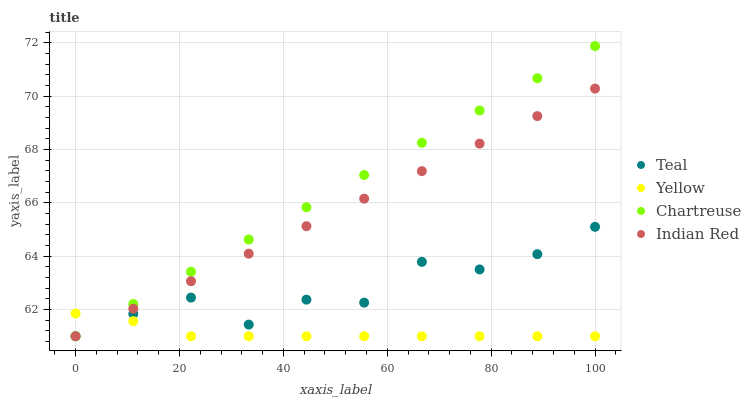Does Yellow have the minimum area under the curve?
Answer yes or no. Yes. Does Chartreuse have the maximum area under the curve?
Answer yes or no. Yes. Does Chartreuse have the minimum area under the curve?
Answer yes or no. No. Does Yellow have the maximum area under the curve?
Answer yes or no. No. Is Indian Red the smoothest?
Answer yes or no. Yes. Is Teal the roughest?
Answer yes or no. Yes. Is Chartreuse the smoothest?
Answer yes or no. No. Is Chartreuse the roughest?
Answer yes or no. No. Does Indian Red have the lowest value?
Answer yes or no. Yes. Does Chartreuse have the highest value?
Answer yes or no. Yes. Does Yellow have the highest value?
Answer yes or no. No. Does Chartreuse intersect Yellow?
Answer yes or no. Yes. Is Chartreuse less than Yellow?
Answer yes or no. No. Is Chartreuse greater than Yellow?
Answer yes or no. No. 